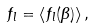Convert formula to latex. <formula><loc_0><loc_0><loc_500><loc_500>f _ { l } = \left \langle f _ { l } ( \beta ) \right \rangle ,</formula> 